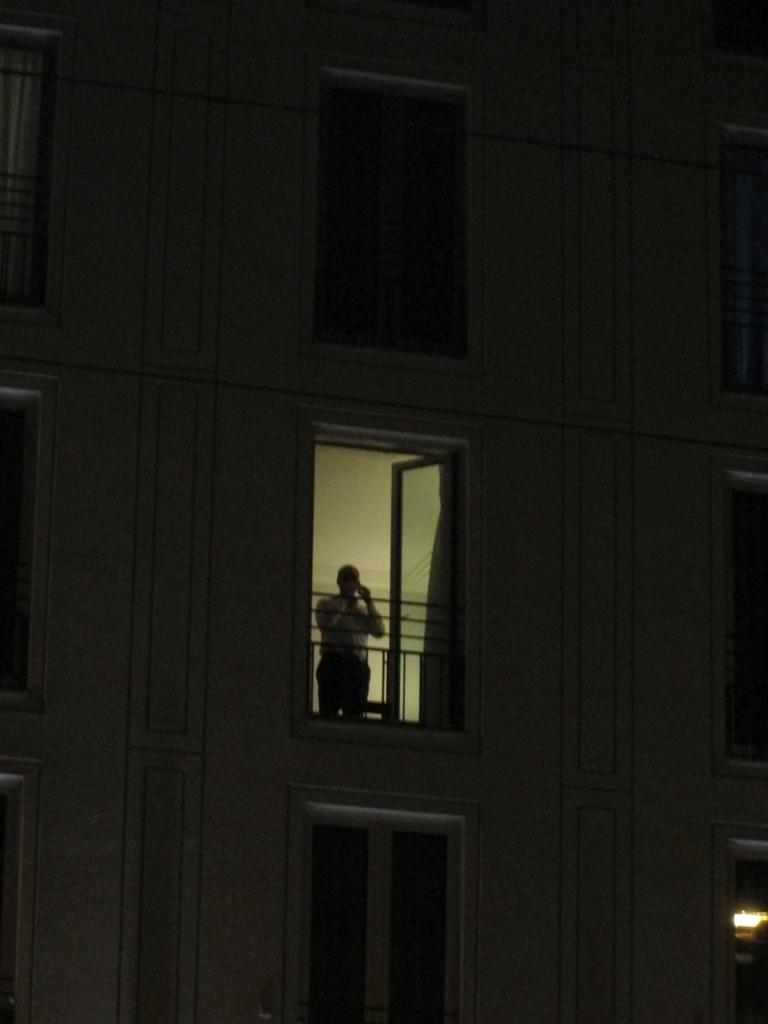What type of structure is present in the image? There is a building in the image. What feature can be observed on the building? The building has windows. Can you describe the presence of a person in the image? There is a person standing in the image. What can be seen that provides illumination in the image? There is a light visible in the image. How many baskets of twigs are being harvested by the person in the image? There is no mention of baskets or twigs in the image; it features a building, windows, a person, and a light source. 